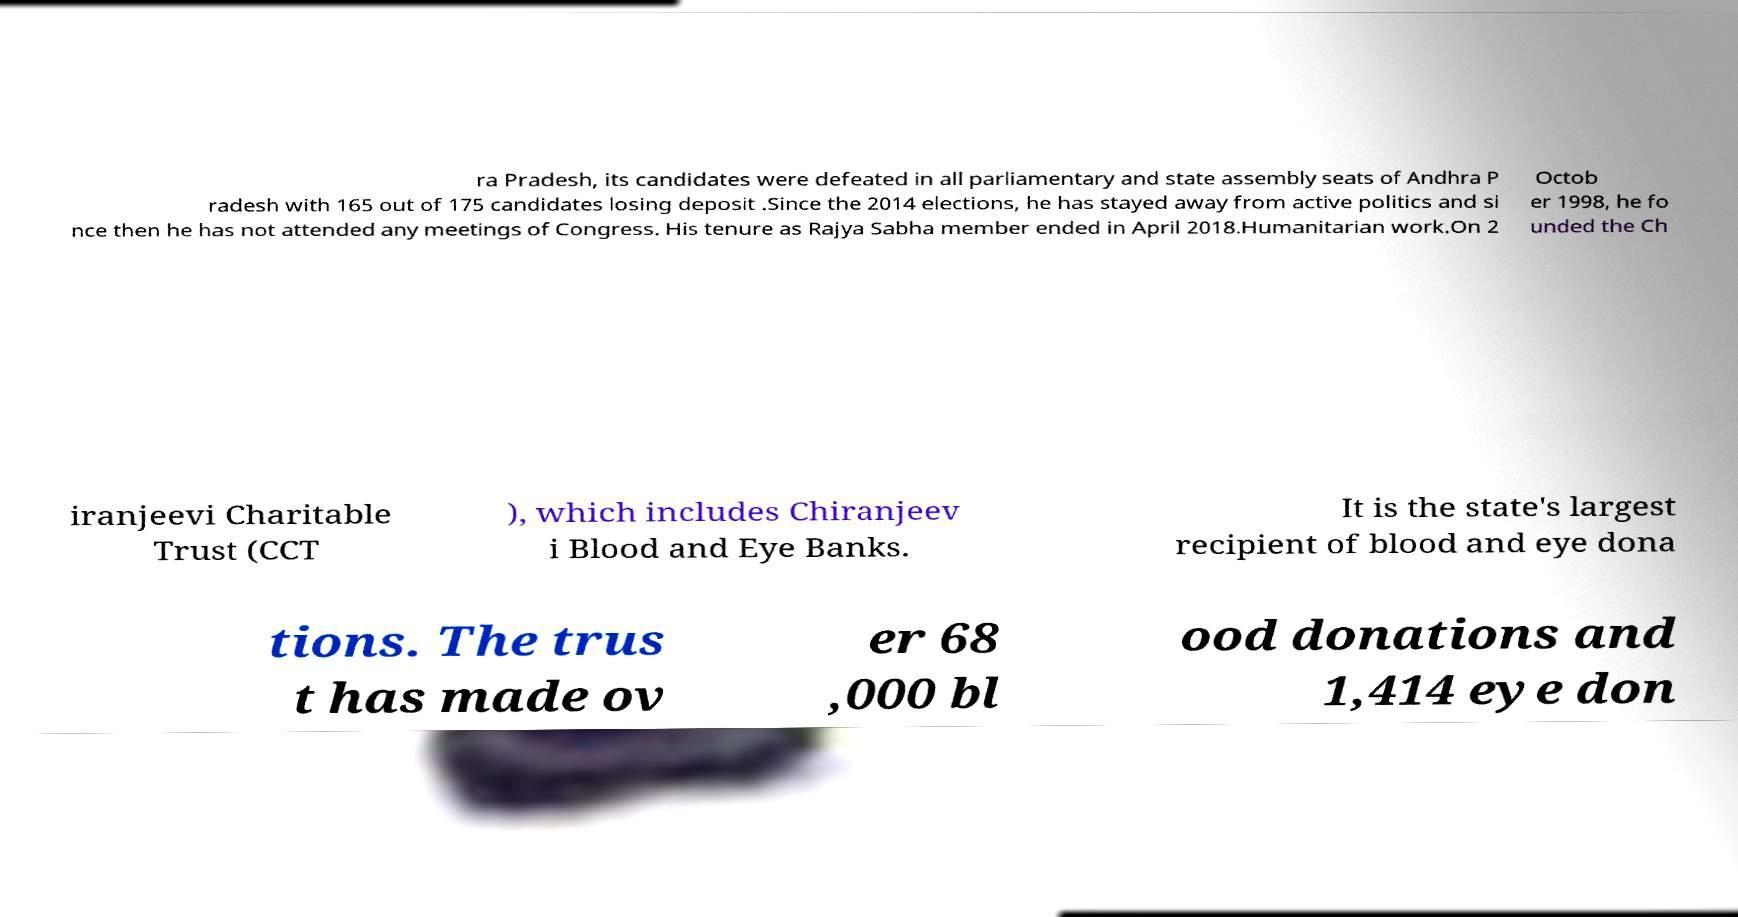For documentation purposes, I need the text within this image transcribed. Could you provide that? ra Pradesh, its candidates were defeated in all parliamentary and state assembly seats of Andhra P radesh with 165 out of 175 candidates losing deposit .Since the 2014 elections, he has stayed away from active politics and si nce then he has not attended any meetings of Congress. His tenure as Rajya Sabha member ended in April 2018.Humanitarian work.On 2 Octob er 1998, he fo unded the Ch iranjeevi Charitable Trust (CCT ), which includes Chiranjeev i Blood and Eye Banks. It is the state's largest recipient of blood and eye dona tions. The trus t has made ov er 68 ,000 bl ood donations and 1,414 eye don 